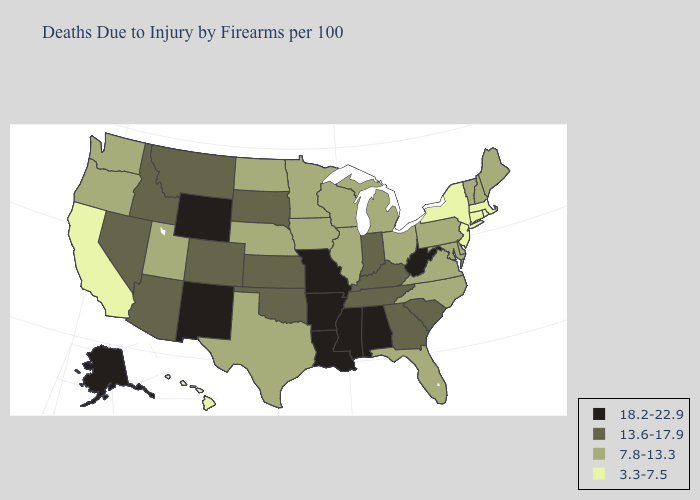What is the lowest value in states that border Kansas?
Short answer required. 7.8-13.3. Name the states that have a value in the range 7.8-13.3?
Concise answer only. Delaware, Florida, Illinois, Iowa, Maine, Maryland, Michigan, Minnesota, Nebraska, New Hampshire, North Carolina, North Dakota, Ohio, Oregon, Pennsylvania, Texas, Utah, Vermont, Virginia, Washington, Wisconsin. Name the states that have a value in the range 18.2-22.9?
Give a very brief answer. Alabama, Alaska, Arkansas, Louisiana, Mississippi, Missouri, New Mexico, West Virginia, Wyoming. What is the highest value in the South ?
Quick response, please. 18.2-22.9. Among the states that border Arizona , does New Mexico have the highest value?
Give a very brief answer. Yes. Name the states that have a value in the range 3.3-7.5?
Keep it brief. California, Connecticut, Hawaii, Massachusetts, New Jersey, New York, Rhode Island. What is the value of South Dakota?
Write a very short answer. 13.6-17.9. What is the highest value in the South ?
Quick response, please. 18.2-22.9. What is the value of Washington?
Write a very short answer. 7.8-13.3. Does Rhode Island have the lowest value in the Northeast?
Be succinct. Yes. Which states have the lowest value in the USA?
Answer briefly. California, Connecticut, Hawaii, Massachusetts, New Jersey, New York, Rhode Island. Does Mississippi have the highest value in the USA?
Keep it brief. Yes. Which states have the lowest value in the USA?
Quick response, please. California, Connecticut, Hawaii, Massachusetts, New Jersey, New York, Rhode Island. Among the states that border Georgia , which have the lowest value?
Answer briefly. Florida, North Carolina. What is the lowest value in the Northeast?
Be succinct. 3.3-7.5. 